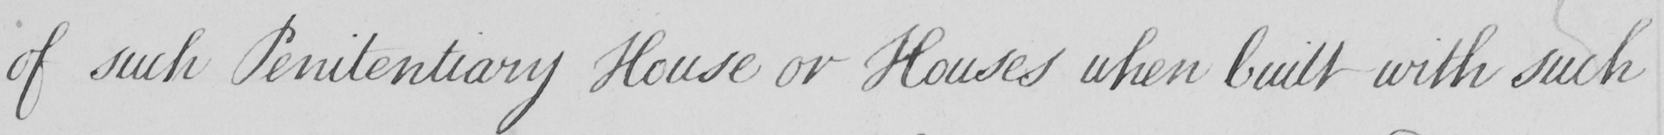What does this handwritten line say? of such Penitentiary House or Houses when built with such 